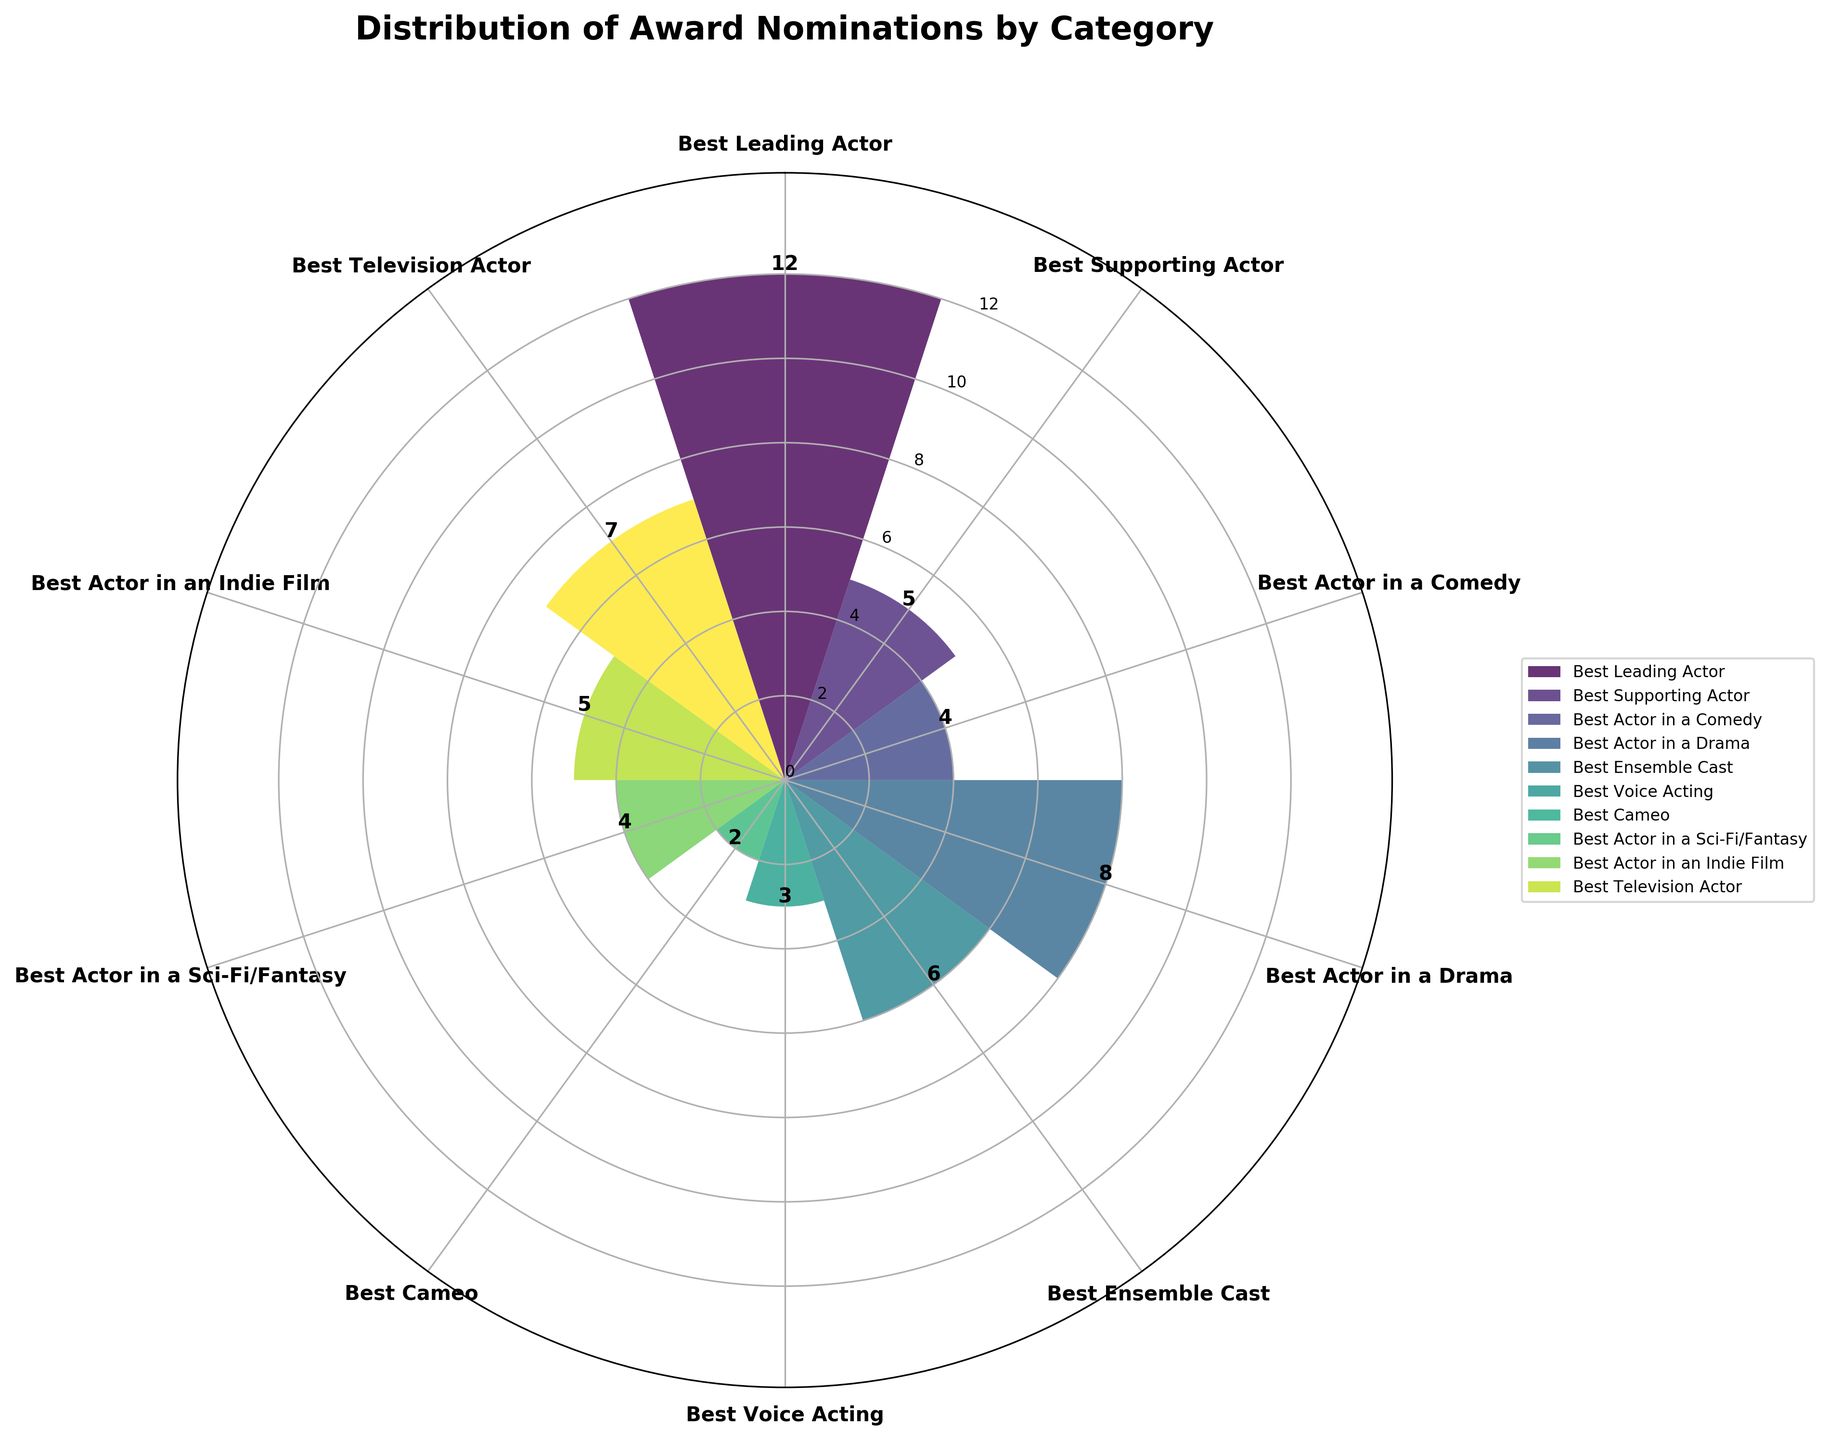Which category has the highest nomination count? To determine the category with the highest nomination count, look at the heights of the bars in the rose chart. The tallest bar represents the category with the highest count.
Answer: Best Leading Actor How many categories have a nomination count of 5 or more? To find the number of categories with a nomination count of 5 or more, count the bars whose heights are 5 or more. These include categories with bars reaching up to 5, 6, 7, 8, etc.
Answer: 6 Which category has the fewest nominations? Identify the shortest bar in the rose chart. The category label corresponding to this bar indicates the category with the fewest nominations.
Answer: Best Cameo How many total nominations are there across all categories? Add the nomination counts of all categories: 12 + 5 + 4 + 8 + 6 + 3 + 2 + 4 + 5 + 7. Summing these values provides the total nominations.
Answer: 56 What is the average nomination count per category? Calculate the total number of nominations (56) and divide by the number of categories (10). This operation gives the average count: 56 / 10.
Answer: 5.6 Which category comes second in terms of the number of nominations? After identifying the category with the highest count (Best Leading Actor), find the bar with the next highest value, which corresponds to the second place.
Answer: Best Actor in a Drama Compare the number of nominations for Best Television Actor and Best Ensemble Cast. Which one has more nominations? Check the height of the bars for Best Television Actor and Best Ensemble Cast. The category with the taller bar has more nominations.
Answer: Best Television Actor If we group Comedy, Drama, and Sci-Fi/Fantasy categories together, how many nominations do they have in total? Add the nominations for Best Actor in a Comedy (4), Best Actor in a Drama (8), and Best Actor in a Sci-Fi/Fantasy (4): 4 + 8 + 4. The sum provides the total nominations for these categories.
Answer: 16 Which categories have a nomination count greater than the average nomination count? First, find the average count (5.6). Then, identify categories with a count higher than this value.
Answer: Best Leading Actor, Best Actor in a Drama, Best Television Actor 